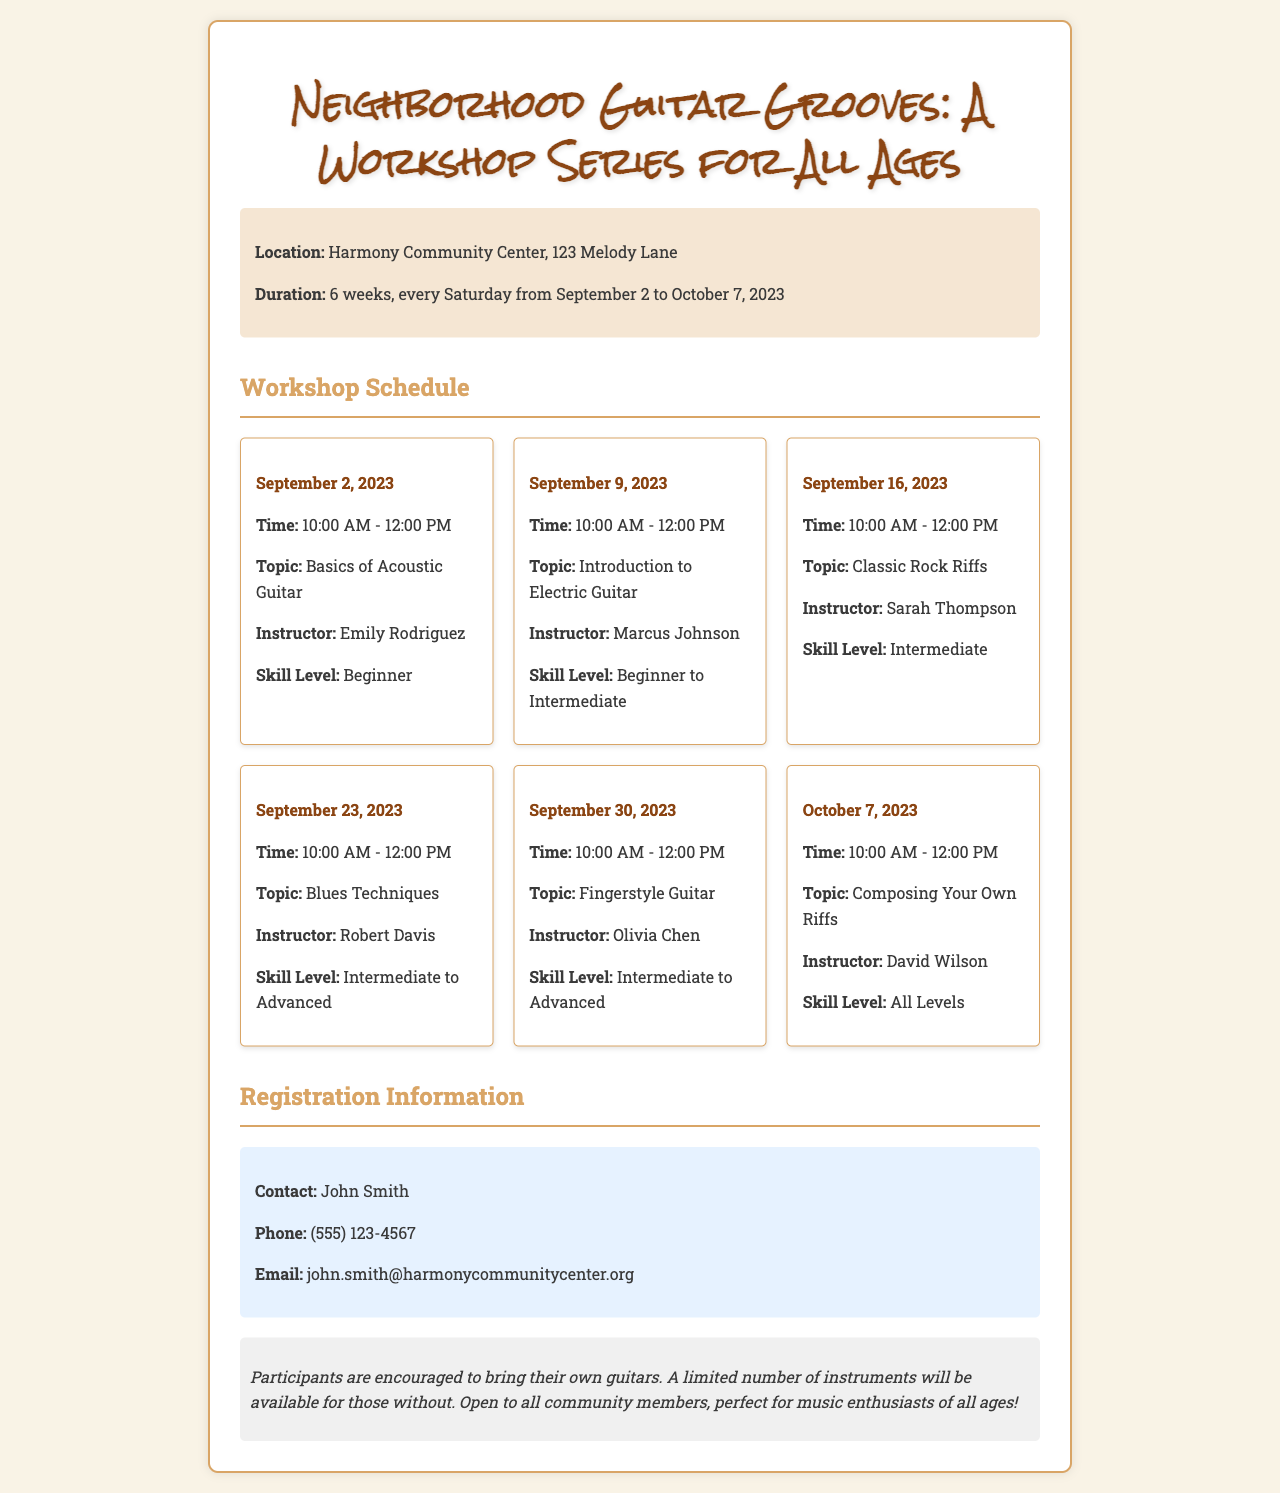What is the location of the workshops? The location is mentioned in the workshop info section of the document.
Answer: Harmony Community Center, 123 Melody Lane When does the workshop series start? The start date is specified in the duration section of the workshop info.
Answer: September 2, 2023 Who is the instructor for the "Blues Techniques" workshop? The instructor is listed under the specific workshop details.
Answer: Robert Davis What skill level is required for the "Fingerstyle Guitar" workshop? The skill level is provided in the workshop details.
Answer: Intermediate to Advanced How many weeks does the workshop series last? The duration is explicitly stated in the workshop info section.
Answer: 6 weeks Which workshop focuses on composing? This is indicated in the workshop schedule by the provided topic.
Answer: Composing Your Own Riffs What time does each workshop start? The start time is consistent across all workshop details in the schedule.
Answer: 10:00 AM What is the contact email for registration? The registration information includes a specific email address.
Answer: john.smith@harmonycommunitycenter.org Are participants required to bring their own instruments? The additional notes section mentions instrument availability.
Answer: Yes 